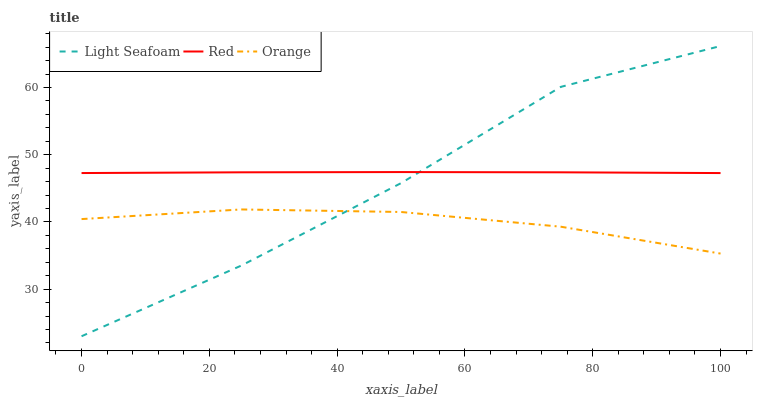Does Orange have the minimum area under the curve?
Answer yes or no. Yes. Does Red have the maximum area under the curve?
Answer yes or no. Yes. Does Light Seafoam have the minimum area under the curve?
Answer yes or no. No. Does Light Seafoam have the maximum area under the curve?
Answer yes or no. No. Is Red the smoothest?
Answer yes or no. Yes. Is Light Seafoam the roughest?
Answer yes or no. Yes. Is Light Seafoam the smoothest?
Answer yes or no. No. Is Red the roughest?
Answer yes or no. No. Does Light Seafoam have the lowest value?
Answer yes or no. Yes. Does Red have the lowest value?
Answer yes or no. No. Does Light Seafoam have the highest value?
Answer yes or no. Yes. Does Red have the highest value?
Answer yes or no. No. Is Orange less than Red?
Answer yes or no. Yes. Is Red greater than Orange?
Answer yes or no. Yes. Does Red intersect Light Seafoam?
Answer yes or no. Yes. Is Red less than Light Seafoam?
Answer yes or no. No. Is Red greater than Light Seafoam?
Answer yes or no. No. Does Orange intersect Red?
Answer yes or no. No. 